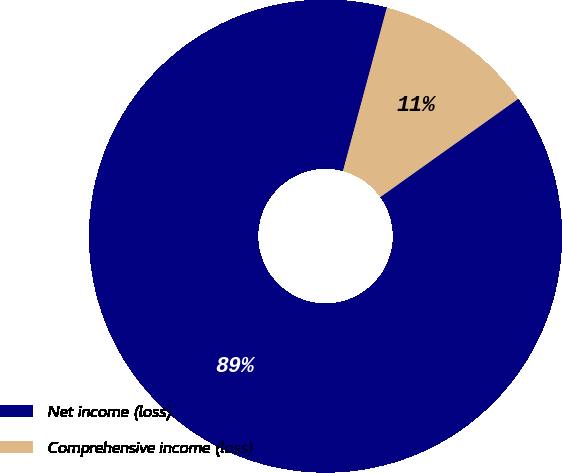Convert chart to OTSL. <chart><loc_0><loc_0><loc_500><loc_500><pie_chart><fcel>Net income (loss)<fcel>Comprehensive income (loss)<nl><fcel>89.03%<fcel>10.97%<nl></chart> 